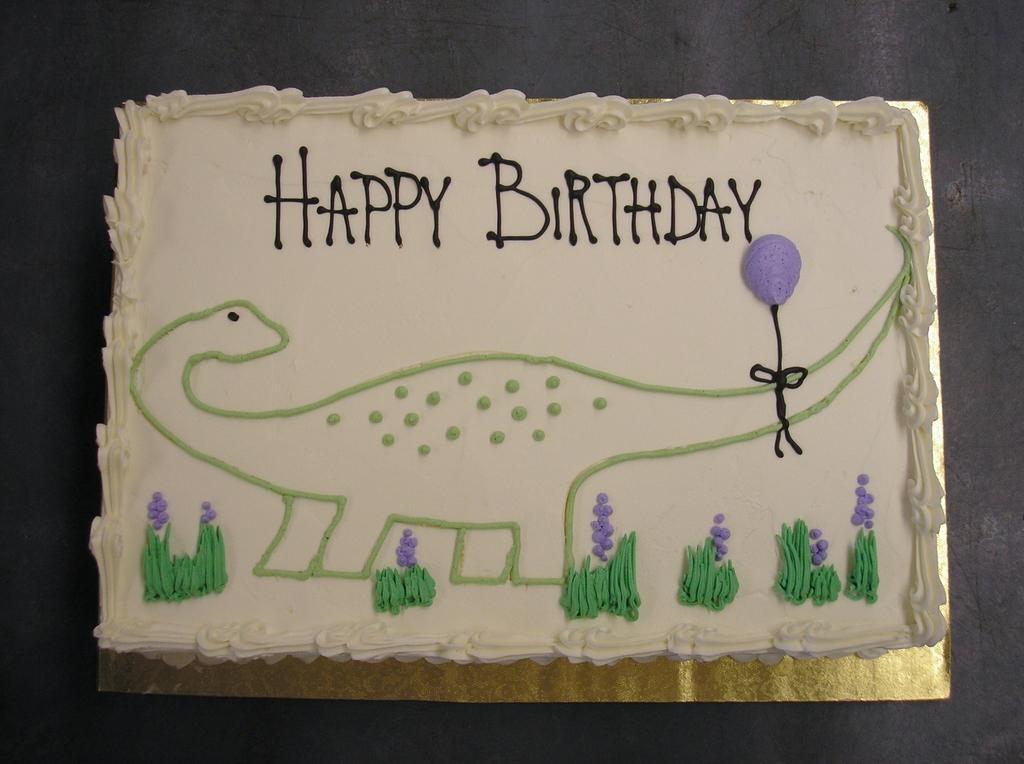In one or two sentences, can you explain what this image depicts? In this picture I can see there is a cake placed on the golden cardboard and there is something written on it and there is a dragon on the cake. It is placed on the black surface. 